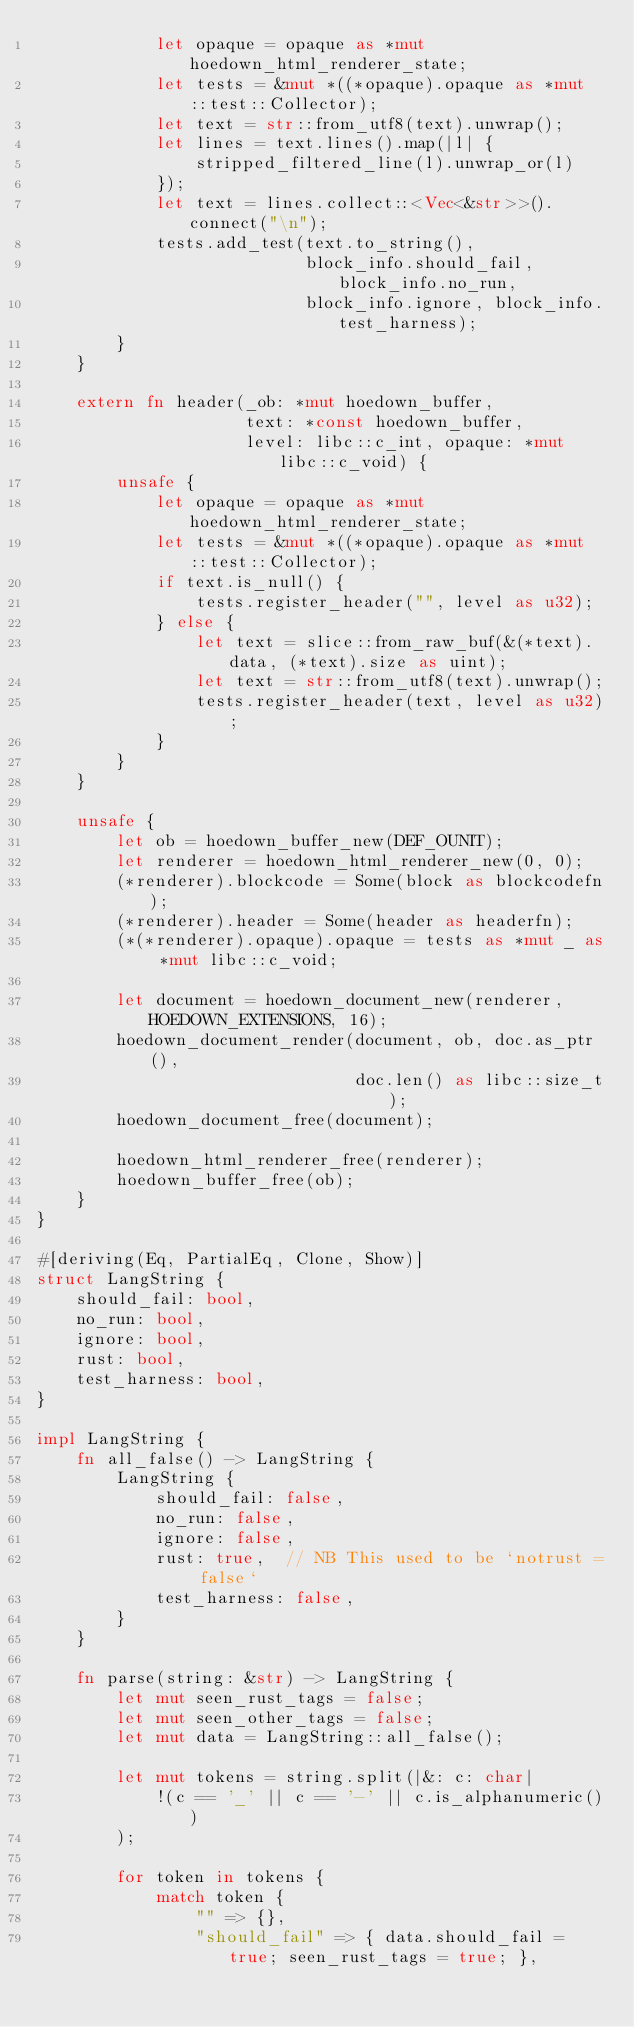<code> <loc_0><loc_0><loc_500><loc_500><_Rust_>            let opaque = opaque as *mut hoedown_html_renderer_state;
            let tests = &mut *((*opaque).opaque as *mut ::test::Collector);
            let text = str::from_utf8(text).unwrap();
            let lines = text.lines().map(|l| {
                stripped_filtered_line(l).unwrap_or(l)
            });
            let text = lines.collect::<Vec<&str>>().connect("\n");
            tests.add_test(text.to_string(),
                           block_info.should_fail, block_info.no_run,
                           block_info.ignore, block_info.test_harness);
        }
    }

    extern fn header(_ob: *mut hoedown_buffer,
                     text: *const hoedown_buffer,
                     level: libc::c_int, opaque: *mut libc::c_void) {
        unsafe {
            let opaque = opaque as *mut hoedown_html_renderer_state;
            let tests = &mut *((*opaque).opaque as *mut ::test::Collector);
            if text.is_null() {
                tests.register_header("", level as u32);
            } else {
                let text = slice::from_raw_buf(&(*text).data, (*text).size as uint);
                let text = str::from_utf8(text).unwrap();
                tests.register_header(text, level as u32);
            }
        }
    }

    unsafe {
        let ob = hoedown_buffer_new(DEF_OUNIT);
        let renderer = hoedown_html_renderer_new(0, 0);
        (*renderer).blockcode = Some(block as blockcodefn);
        (*renderer).header = Some(header as headerfn);
        (*(*renderer).opaque).opaque = tests as *mut _ as *mut libc::c_void;

        let document = hoedown_document_new(renderer, HOEDOWN_EXTENSIONS, 16);
        hoedown_document_render(document, ob, doc.as_ptr(),
                                doc.len() as libc::size_t);
        hoedown_document_free(document);

        hoedown_html_renderer_free(renderer);
        hoedown_buffer_free(ob);
    }
}

#[deriving(Eq, PartialEq, Clone, Show)]
struct LangString {
    should_fail: bool,
    no_run: bool,
    ignore: bool,
    rust: bool,
    test_harness: bool,
}

impl LangString {
    fn all_false() -> LangString {
        LangString {
            should_fail: false,
            no_run: false,
            ignore: false,
            rust: true,  // NB This used to be `notrust = false`
            test_harness: false,
        }
    }

    fn parse(string: &str) -> LangString {
        let mut seen_rust_tags = false;
        let mut seen_other_tags = false;
        let mut data = LangString::all_false();

        let mut tokens = string.split(|&: c: char|
            !(c == '_' || c == '-' || c.is_alphanumeric())
        );

        for token in tokens {
            match token {
                "" => {},
                "should_fail" => { data.should_fail = true; seen_rust_tags = true; },</code> 